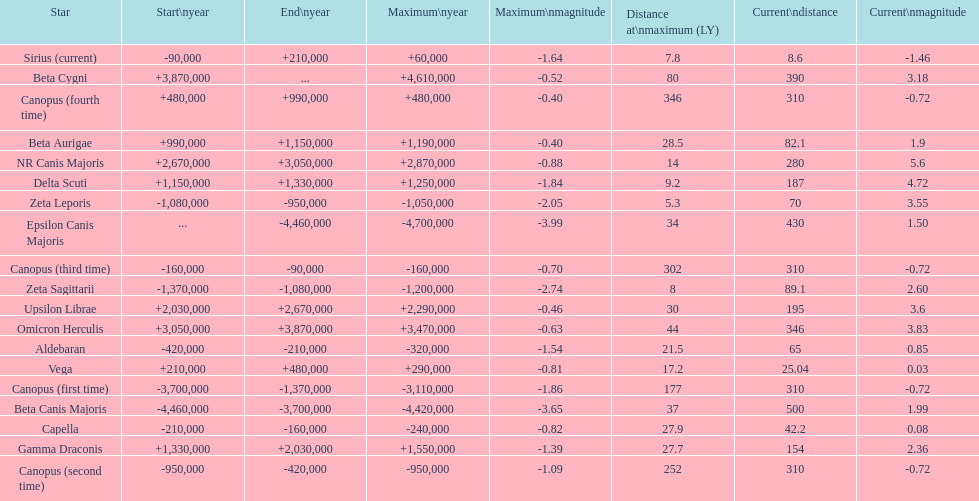How much farther (in ly) is epsilon canis majoris than zeta sagittarii? 26. 